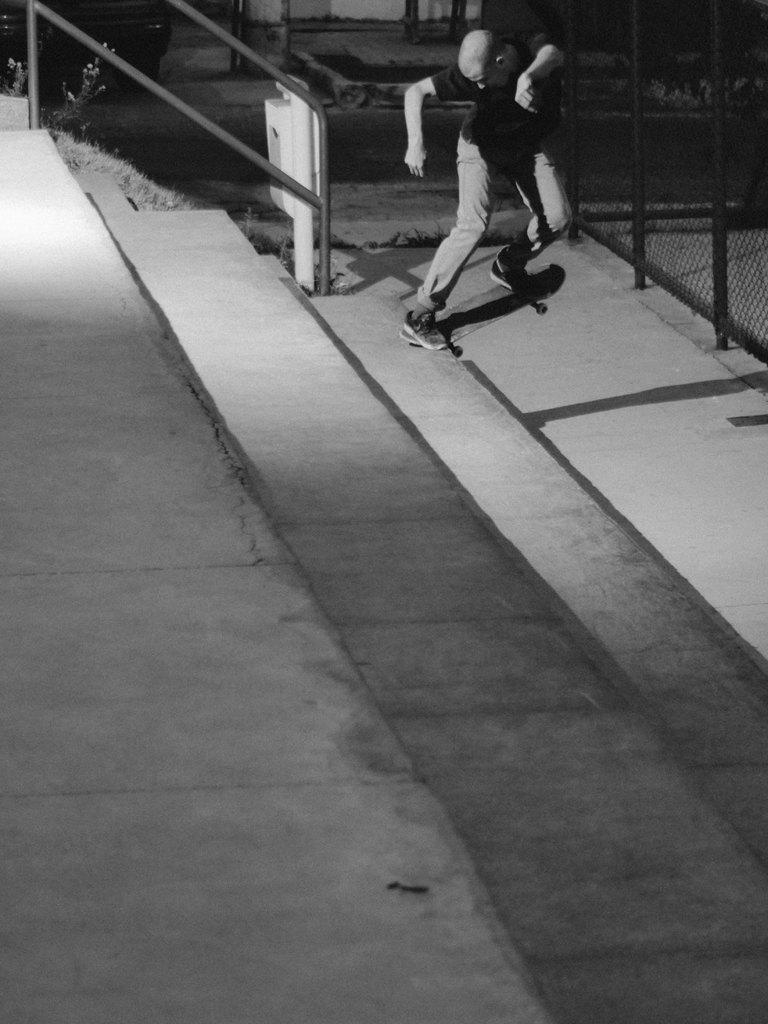Who is the main subject in the image? There is a boy in the image. What is the boy doing in the image? The boy is skating. What can be seen in the center of the image? There are stairs in the center of the image. What is located on the right side of the image? There is a net boundary on the right side of the image. What type of quilt is being used by the boy while skating in the image? There is no quilt present in the image; the boy is skating without any additional covering or protection. 